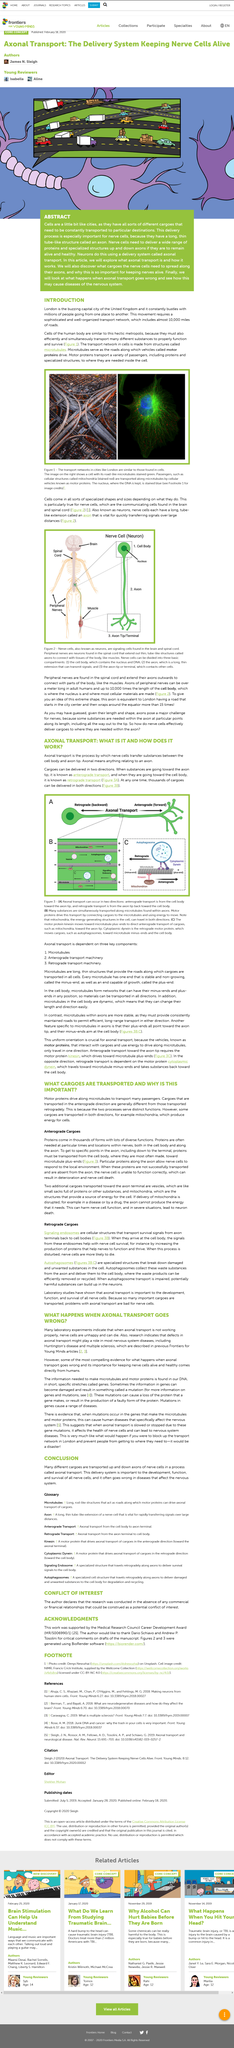Identify some key points in this picture. London is the capital of the United Kingdom. Yes, cytoplasmic dynein transports towards the non-growing end of the microtubule. Proteins such as kinesin and cytoplasmic dynein are responsible for transporting cargo along microtubules. In adult human peripheral nerves, axons can extend up to 10,000 times the length of the cell body. The London transport network has an extensive network of roads, with almost 10,000 miles of roads, making it a vital component of the city's transportation system. 